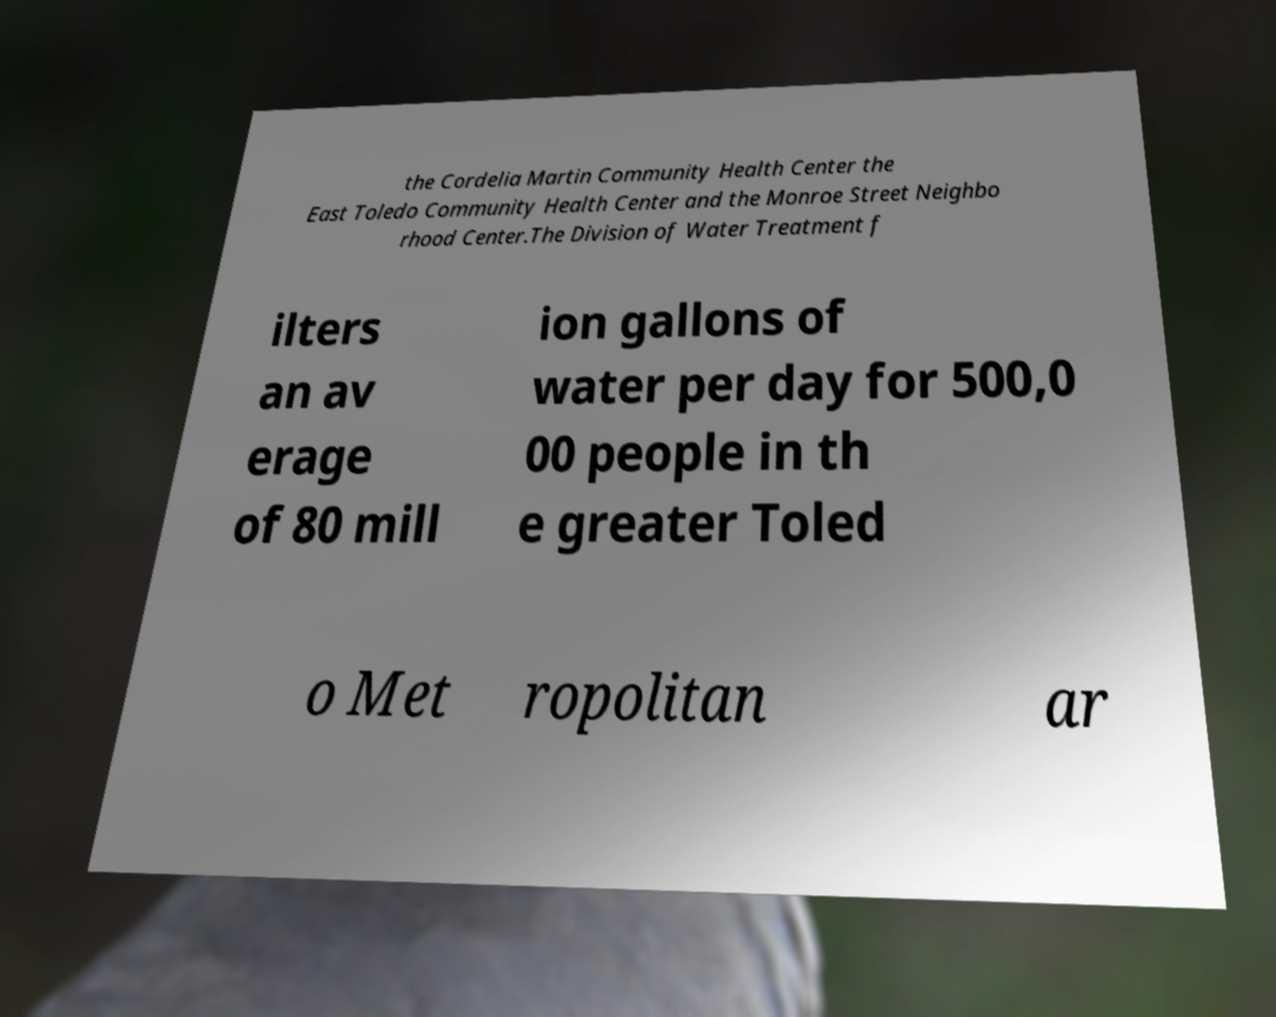Please identify and transcribe the text found in this image. the Cordelia Martin Community Health Center the East Toledo Community Health Center and the Monroe Street Neighbo rhood Center.The Division of Water Treatment f ilters an av erage of 80 mill ion gallons of water per day for 500,0 00 people in th e greater Toled o Met ropolitan ar 